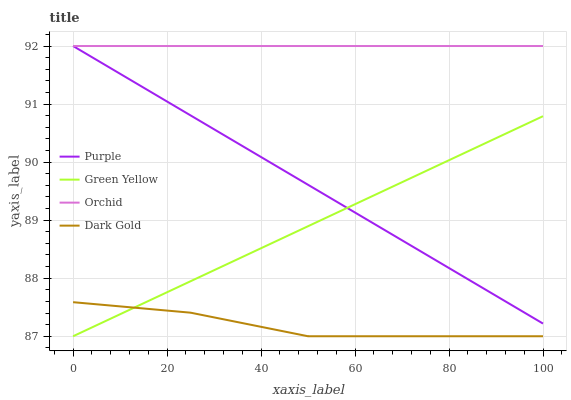Does Green Yellow have the minimum area under the curve?
Answer yes or no. No. Does Green Yellow have the maximum area under the curve?
Answer yes or no. No. Is Green Yellow the smoothest?
Answer yes or no. No. Is Green Yellow the roughest?
Answer yes or no. No. Does Orchid have the lowest value?
Answer yes or no. No. Does Green Yellow have the highest value?
Answer yes or no. No. Is Dark Gold less than Purple?
Answer yes or no. Yes. Is Orchid greater than Dark Gold?
Answer yes or no. Yes. Does Dark Gold intersect Purple?
Answer yes or no. No. 